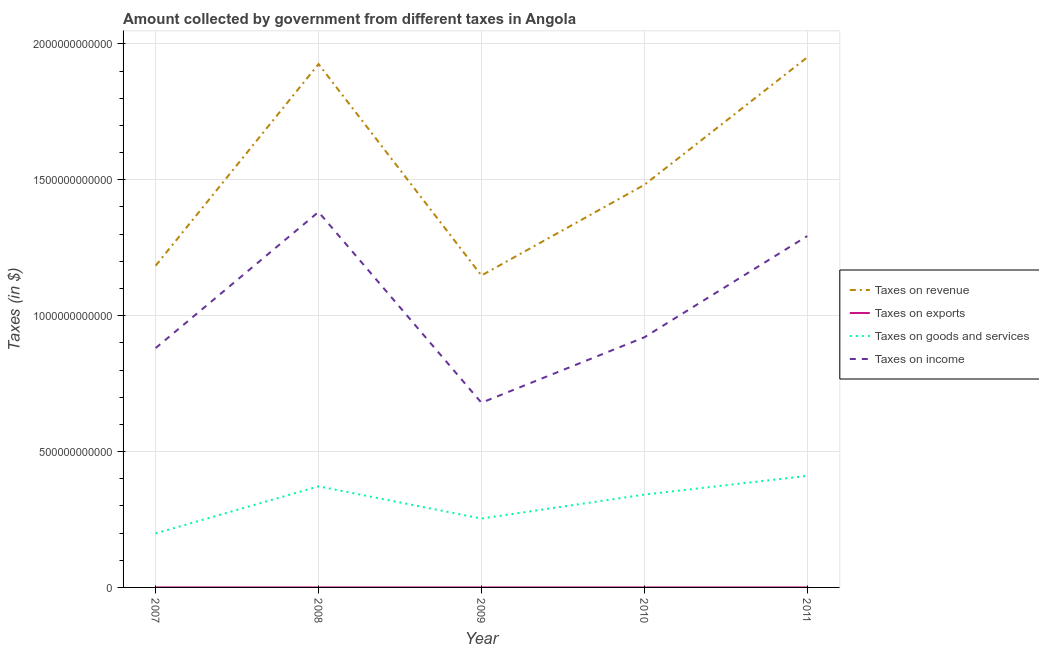How many different coloured lines are there?
Offer a very short reply. 4. Is the number of lines equal to the number of legend labels?
Provide a short and direct response. Yes. What is the amount collected as tax on income in 2010?
Provide a short and direct response. 9.20e+11. Across all years, what is the maximum amount collected as tax on goods?
Make the answer very short. 4.10e+11. Across all years, what is the minimum amount collected as tax on exports?
Ensure brevity in your answer.  7.26e+06. In which year was the amount collected as tax on goods minimum?
Offer a very short reply. 2007. What is the total amount collected as tax on goods in the graph?
Keep it short and to the point. 1.58e+12. What is the difference between the amount collected as tax on goods in 2007 and that in 2010?
Your answer should be very brief. -1.43e+11. What is the difference between the amount collected as tax on exports in 2011 and the amount collected as tax on income in 2010?
Give a very brief answer. -9.20e+11. What is the average amount collected as tax on income per year?
Provide a short and direct response. 1.03e+12. In the year 2010, what is the difference between the amount collected as tax on income and amount collected as tax on revenue?
Make the answer very short. -5.61e+11. What is the ratio of the amount collected as tax on income in 2007 to that in 2010?
Keep it short and to the point. 0.96. What is the difference between the highest and the second highest amount collected as tax on revenue?
Provide a short and direct response. 2.48e+1. What is the difference between the highest and the lowest amount collected as tax on revenue?
Give a very brief answer. 8.03e+11. Is the sum of the amount collected as tax on income in 2010 and 2011 greater than the maximum amount collected as tax on goods across all years?
Provide a short and direct response. Yes. Is it the case that in every year, the sum of the amount collected as tax on income and amount collected as tax on goods is greater than the sum of amount collected as tax on exports and amount collected as tax on revenue?
Provide a succinct answer. Yes. Is it the case that in every year, the sum of the amount collected as tax on revenue and amount collected as tax on exports is greater than the amount collected as tax on goods?
Give a very brief answer. Yes. Does the amount collected as tax on income monotonically increase over the years?
Keep it short and to the point. No. Is the amount collected as tax on goods strictly greater than the amount collected as tax on revenue over the years?
Ensure brevity in your answer.  No. Is the amount collected as tax on goods strictly less than the amount collected as tax on revenue over the years?
Make the answer very short. Yes. How many years are there in the graph?
Provide a succinct answer. 5. What is the difference between two consecutive major ticks on the Y-axis?
Keep it short and to the point. 5.00e+11. Does the graph contain grids?
Provide a short and direct response. Yes. How are the legend labels stacked?
Give a very brief answer. Vertical. What is the title of the graph?
Your response must be concise. Amount collected by government from different taxes in Angola. What is the label or title of the X-axis?
Provide a succinct answer. Year. What is the label or title of the Y-axis?
Offer a terse response. Taxes (in $). What is the Taxes (in $) in Taxes on revenue in 2007?
Offer a terse response. 1.18e+12. What is the Taxes (in $) of Taxes on exports in 2007?
Make the answer very short. 7.12e+07. What is the Taxes (in $) of Taxes on goods and services in 2007?
Offer a terse response. 1.99e+11. What is the Taxes (in $) in Taxes on income in 2007?
Your answer should be compact. 8.81e+11. What is the Taxes (in $) of Taxes on revenue in 2008?
Your answer should be very brief. 1.93e+12. What is the Taxes (in $) of Taxes on exports in 2008?
Give a very brief answer. 9.73e+06. What is the Taxes (in $) in Taxes on goods and services in 2008?
Offer a terse response. 3.72e+11. What is the Taxes (in $) in Taxes on income in 2008?
Make the answer very short. 1.38e+12. What is the Taxes (in $) of Taxes on revenue in 2009?
Make the answer very short. 1.15e+12. What is the Taxes (in $) of Taxes on exports in 2009?
Provide a short and direct response. 7.26e+06. What is the Taxes (in $) in Taxes on goods and services in 2009?
Your response must be concise. 2.53e+11. What is the Taxes (in $) of Taxes on income in 2009?
Provide a short and direct response. 6.80e+11. What is the Taxes (in $) in Taxes on revenue in 2010?
Provide a short and direct response. 1.48e+12. What is the Taxes (in $) in Taxes on exports in 2010?
Your answer should be very brief. 1.07e+07. What is the Taxes (in $) of Taxes on goods and services in 2010?
Your response must be concise. 3.42e+11. What is the Taxes (in $) in Taxes on income in 2010?
Your response must be concise. 9.20e+11. What is the Taxes (in $) of Taxes on revenue in 2011?
Your answer should be compact. 1.95e+12. What is the Taxes (in $) of Taxes on exports in 2011?
Provide a short and direct response. 1.11e+07. What is the Taxes (in $) in Taxes on goods and services in 2011?
Your answer should be compact. 4.10e+11. What is the Taxes (in $) of Taxes on income in 2011?
Offer a terse response. 1.29e+12. Across all years, what is the maximum Taxes (in $) of Taxes on revenue?
Keep it short and to the point. 1.95e+12. Across all years, what is the maximum Taxes (in $) in Taxes on exports?
Keep it short and to the point. 7.12e+07. Across all years, what is the maximum Taxes (in $) of Taxes on goods and services?
Your response must be concise. 4.10e+11. Across all years, what is the maximum Taxes (in $) in Taxes on income?
Ensure brevity in your answer.  1.38e+12. Across all years, what is the minimum Taxes (in $) of Taxes on revenue?
Keep it short and to the point. 1.15e+12. Across all years, what is the minimum Taxes (in $) of Taxes on exports?
Keep it short and to the point. 7.26e+06. Across all years, what is the minimum Taxes (in $) in Taxes on goods and services?
Your response must be concise. 1.99e+11. Across all years, what is the minimum Taxes (in $) of Taxes on income?
Offer a terse response. 6.80e+11. What is the total Taxes (in $) in Taxes on revenue in the graph?
Your answer should be compact. 7.69e+12. What is the total Taxes (in $) in Taxes on exports in the graph?
Make the answer very short. 1.10e+08. What is the total Taxes (in $) in Taxes on goods and services in the graph?
Offer a terse response. 1.58e+12. What is the total Taxes (in $) in Taxes on income in the graph?
Offer a very short reply. 5.16e+12. What is the difference between the Taxes (in $) in Taxes on revenue in 2007 and that in 2008?
Provide a succinct answer. -7.42e+11. What is the difference between the Taxes (in $) in Taxes on exports in 2007 and that in 2008?
Make the answer very short. 6.14e+07. What is the difference between the Taxes (in $) of Taxes on goods and services in 2007 and that in 2008?
Provide a short and direct response. -1.73e+11. What is the difference between the Taxes (in $) of Taxes on income in 2007 and that in 2008?
Keep it short and to the point. -5.01e+11. What is the difference between the Taxes (in $) of Taxes on revenue in 2007 and that in 2009?
Give a very brief answer. 3.61e+1. What is the difference between the Taxes (in $) in Taxes on exports in 2007 and that in 2009?
Give a very brief answer. 6.39e+07. What is the difference between the Taxes (in $) in Taxes on goods and services in 2007 and that in 2009?
Ensure brevity in your answer.  -5.47e+1. What is the difference between the Taxes (in $) of Taxes on income in 2007 and that in 2009?
Your response must be concise. 2.01e+11. What is the difference between the Taxes (in $) in Taxes on revenue in 2007 and that in 2010?
Provide a succinct answer. -2.97e+11. What is the difference between the Taxes (in $) in Taxes on exports in 2007 and that in 2010?
Offer a terse response. 6.04e+07. What is the difference between the Taxes (in $) of Taxes on goods and services in 2007 and that in 2010?
Your answer should be compact. -1.43e+11. What is the difference between the Taxes (in $) in Taxes on income in 2007 and that in 2010?
Make the answer very short. -3.97e+1. What is the difference between the Taxes (in $) in Taxes on revenue in 2007 and that in 2011?
Provide a short and direct response. -7.67e+11. What is the difference between the Taxes (in $) in Taxes on exports in 2007 and that in 2011?
Keep it short and to the point. 6.00e+07. What is the difference between the Taxes (in $) of Taxes on goods and services in 2007 and that in 2011?
Give a very brief answer. -2.12e+11. What is the difference between the Taxes (in $) in Taxes on income in 2007 and that in 2011?
Provide a short and direct response. -4.12e+11. What is the difference between the Taxes (in $) of Taxes on revenue in 2008 and that in 2009?
Provide a short and direct response. 7.78e+11. What is the difference between the Taxes (in $) in Taxes on exports in 2008 and that in 2009?
Keep it short and to the point. 2.47e+06. What is the difference between the Taxes (in $) in Taxes on goods and services in 2008 and that in 2009?
Your answer should be compact. 1.18e+11. What is the difference between the Taxes (in $) in Taxes on income in 2008 and that in 2009?
Offer a terse response. 7.02e+11. What is the difference between the Taxes (in $) in Taxes on revenue in 2008 and that in 2010?
Provide a succinct answer. 4.44e+11. What is the difference between the Taxes (in $) of Taxes on exports in 2008 and that in 2010?
Keep it short and to the point. -9.83e+05. What is the difference between the Taxes (in $) of Taxes on goods and services in 2008 and that in 2010?
Offer a terse response. 3.04e+1. What is the difference between the Taxes (in $) in Taxes on income in 2008 and that in 2010?
Provide a short and direct response. 4.61e+11. What is the difference between the Taxes (in $) of Taxes on revenue in 2008 and that in 2011?
Make the answer very short. -2.48e+1. What is the difference between the Taxes (in $) in Taxes on exports in 2008 and that in 2011?
Make the answer very short. -1.39e+06. What is the difference between the Taxes (in $) in Taxes on goods and services in 2008 and that in 2011?
Provide a succinct answer. -3.86e+1. What is the difference between the Taxes (in $) in Taxes on income in 2008 and that in 2011?
Give a very brief answer. 8.87e+1. What is the difference between the Taxes (in $) of Taxes on revenue in 2009 and that in 2010?
Keep it short and to the point. -3.34e+11. What is the difference between the Taxes (in $) in Taxes on exports in 2009 and that in 2010?
Your response must be concise. -3.46e+06. What is the difference between the Taxes (in $) in Taxes on goods and services in 2009 and that in 2010?
Your answer should be compact. -8.80e+1. What is the difference between the Taxes (in $) in Taxes on income in 2009 and that in 2010?
Make the answer very short. -2.41e+11. What is the difference between the Taxes (in $) in Taxes on revenue in 2009 and that in 2011?
Offer a terse response. -8.03e+11. What is the difference between the Taxes (in $) in Taxes on exports in 2009 and that in 2011?
Your answer should be compact. -3.86e+06. What is the difference between the Taxes (in $) in Taxes on goods and services in 2009 and that in 2011?
Provide a short and direct response. -1.57e+11. What is the difference between the Taxes (in $) of Taxes on income in 2009 and that in 2011?
Offer a very short reply. -6.13e+11. What is the difference between the Taxes (in $) in Taxes on revenue in 2010 and that in 2011?
Provide a succinct answer. -4.69e+11. What is the difference between the Taxes (in $) in Taxes on exports in 2010 and that in 2011?
Provide a succinct answer. -4.03e+05. What is the difference between the Taxes (in $) in Taxes on goods and services in 2010 and that in 2011?
Ensure brevity in your answer.  -6.89e+1. What is the difference between the Taxes (in $) of Taxes on income in 2010 and that in 2011?
Provide a succinct answer. -3.73e+11. What is the difference between the Taxes (in $) of Taxes on revenue in 2007 and the Taxes (in $) of Taxes on exports in 2008?
Provide a succinct answer. 1.18e+12. What is the difference between the Taxes (in $) in Taxes on revenue in 2007 and the Taxes (in $) in Taxes on goods and services in 2008?
Keep it short and to the point. 8.12e+11. What is the difference between the Taxes (in $) in Taxes on revenue in 2007 and the Taxes (in $) in Taxes on income in 2008?
Your answer should be very brief. -1.98e+11. What is the difference between the Taxes (in $) in Taxes on exports in 2007 and the Taxes (in $) in Taxes on goods and services in 2008?
Offer a very short reply. -3.72e+11. What is the difference between the Taxes (in $) in Taxes on exports in 2007 and the Taxes (in $) in Taxes on income in 2008?
Provide a succinct answer. -1.38e+12. What is the difference between the Taxes (in $) in Taxes on goods and services in 2007 and the Taxes (in $) in Taxes on income in 2008?
Make the answer very short. -1.18e+12. What is the difference between the Taxes (in $) in Taxes on revenue in 2007 and the Taxes (in $) in Taxes on exports in 2009?
Give a very brief answer. 1.18e+12. What is the difference between the Taxes (in $) in Taxes on revenue in 2007 and the Taxes (in $) in Taxes on goods and services in 2009?
Offer a terse response. 9.30e+11. What is the difference between the Taxes (in $) in Taxes on revenue in 2007 and the Taxes (in $) in Taxes on income in 2009?
Your answer should be compact. 5.04e+11. What is the difference between the Taxes (in $) in Taxes on exports in 2007 and the Taxes (in $) in Taxes on goods and services in 2009?
Your answer should be compact. -2.53e+11. What is the difference between the Taxes (in $) of Taxes on exports in 2007 and the Taxes (in $) of Taxes on income in 2009?
Make the answer very short. -6.80e+11. What is the difference between the Taxes (in $) in Taxes on goods and services in 2007 and the Taxes (in $) in Taxes on income in 2009?
Offer a very short reply. -4.81e+11. What is the difference between the Taxes (in $) of Taxes on revenue in 2007 and the Taxes (in $) of Taxes on exports in 2010?
Ensure brevity in your answer.  1.18e+12. What is the difference between the Taxes (in $) of Taxes on revenue in 2007 and the Taxes (in $) of Taxes on goods and services in 2010?
Provide a succinct answer. 8.42e+11. What is the difference between the Taxes (in $) in Taxes on revenue in 2007 and the Taxes (in $) in Taxes on income in 2010?
Your response must be concise. 2.64e+11. What is the difference between the Taxes (in $) of Taxes on exports in 2007 and the Taxes (in $) of Taxes on goods and services in 2010?
Offer a terse response. -3.41e+11. What is the difference between the Taxes (in $) in Taxes on exports in 2007 and the Taxes (in $) in Taxes on income in 2010?
Provide a succinct answer. -9.20e+11. What is the difference between the Taxes (in $) in Taxes on goods and services in 2007 and the Taxes (in $) in Taxes on income in 2010?
Provide a succinct answer. -7.22e+11. What is the difference between the Taxes (in $) of Taxes on revenue in 2007 and the Taxes (in $) of Taxes on exports in 2011?
Your answer should be very brief. 1.18e+12. What is the difference between the Taxes (in $) of Taxes on revenue in 2007 and the Taxes (in $) of Taxes on goods and services in 2011?
Make the answer very short. 7.73e+11. What is the difference between the Taxes (in $) of Taxes on revenue in 2007 and the Taxes (in $) of Taxes on income in 2011?
Your answer should be very brief. -1.09e+11. What is the difference between the Taxes (in $) in Taxes on exports in 2007 and the Taxes (in $) in Taxes on goods and services in 2011?
Keep it short and to the point. -4.10e+11. What is the difference between the Taxes (in $) in Taxes on exports in 2007 and the Taxes (in $) in Taxes on income in 2011?
Your answer should be very brief. -1.29e+12. What is the difference between the Taxes (in $) in Taxes on goods and services in 2007 and the Taxes (in $) in Taxes on income in 2011?
Offer a very short reply. -1.09e+12. What is the difference between the Taxes (in $) in Taxes on revenue in 2008 and the Taxes (in $) in Taxes on exports in 2009?
Your response must be concise. 1.93e+12. What is the difference between the Taxes (in $) in Taxes on revenue in 2008 and the Taxes (in $) in Taxes on goods and services in 2009?
Offer a terse response. 1.67e+12. What is the difference between the Taxes (in $) of Taxes on revenue in 2008 and the Taxes (in $) of Taxes on income in 2009?
Ensure brevity in your answer.  1.25e+12. What is the difference between the Taxes (in $) of Taxes on exports in 2008 and the Taxes (in $) of Taxes on goods and services in 2009?
Offer a very short reply. -2.53e+11. What is the difference between the Taxes (in $) in Taxes on exports in 2008 and the Taxes (in $) in Taxes on income in 2009?
Provide a succinct answer. -6.80e+11. What is the difference between the Taxes (in $) of Taxes on goods and services in 2008 and the Taxes (in $) of Taxes on income in 2009?
Your response must be concise. -3.08e+11. What is the difference between the Taxes (in $) in Taxes on revenue in 2008 and the Taxes (in $) in Taxes on exports in 2010?
Offer a very short reply. 1.93e+12. What is the difference between the Taxes (in $) of Taxes on revenue in 2008 and the Taxes (in $) of Taxes on goods and services in 2010?
Give a very brief answer. 1.58e+12. What is the difference between the Taxes (in $) of Taxes on revenue in 2008 and the Taxes (in $) of Taxes on income in 2010?
Offer a terse response. 1.01e+12. What is the difference between the Taxes (in $) in Taxes on exports in 2008 and the Taxes (in $) in Taxes on goods and services in 2010?
Your answer should be very brief. -3.42e+11. What is the difference between the Taxes (in $) of Taxes on exports in 2008 and the Taxes (in $) of Taxes on income in 2010?
Your answer should be very brief. -9.20e+11. What is the difference between the Taxes (in $) in Taxes on goods and services in 2008 and the Taxes (in $) in Taxes on income in 2010?
Your answer should be very brief. -5.48e+11. What is the difference between the Taxes (in $) of Taxes on revenue in 2008 and the Taxes (in $) of Taxes on exports in 2011?
Provide a succinct answer. 1.93e+12. What is the difference between the Taxes (in $) of Taxes on revenue in 2008 and the Taxes (in $) of Taxes on goods and services in 2011?
Your response must be concise. 1.52e+12. What is the difference between the Taxes (in $) in Taxes on revenue in 2008 and the Taxes (in $) in Taxes on income in 2011?
Offer a terse response. 6.33e+11. What is the difference between the Taxes (in $) in Taxes on exports in 2008 and the Taxes (in $) in Taxes on goods and services in 2011?
Your answer should be very brief. -4.10e+11. What is the difference between the Taxes (in $) of Taxes on exports in 2008 and the Taxes (in $) of Taxes on income in 2011?
Ensure brevity in your answer.  -1.29e+12. What is the difference between the Taxes (in $) of Taxes on goods and services in 2008 and the Taxes (in $) of Taxes on income in 2011?
Offer a terse response. -9.21e+11. What is the difference between the Taxes (in $) of Taxes on revenue in 2009 and the Taxes (in $) of Taxes on exports in 2010?
Your answer should be compact. 1.15e+12. What is the difference between the Taxes (in $) in Taxes on revenue in 2009 and the Taxes (in $) in Taxes on goods and services in 2010?
Your response must be concise. 8.06e+11. What is the difference between the Taxes (in $) in Taxes on revenue in 2009 and the Taxes (in $) in Taxes on income in 2010?
Provide a succinct answer. 2.27e+11. What is the difference between the Taxes (in $) of Taxes on exports in 2009 and the Taxes (in $) of Taxes on goods and services in 2010?
Your answer should be compact. -3.42e+11. What is the difference between the Taxes (in $) in Taxes on exports in 2009 and the Taxes (in $) in Taxes on income in 2010?
Keep it short and to the point. -9.20e+11. What is the difference between the Taxes (in $) of Taxes on goods and services in 2009 and the Taxes (in $) of Taxes on income in 2010?
Your response must be concise. -6.67e+11. What is the difference between the Taxes (in $) of Taxes on revenue in 2009 and the Taxes (in $) of Taxes on exports in 2011?
Give a very brief answer. 1.15e+12. What is the difference between the Taxes (in $) in Taxes on revenue in 2009 and the Taxes (in $) in Taxes on goods and services in 2011?
Offer a very short reply. 7.37e+11. What is the difference between the Taxes (in $) in Taxes on revenue in 2009 and the Taxes (in $) in Taxes on income in 2011?
Provide a short and direct response. -1.45e+11. What is the difference between the Taxes (in $) of Taxes on exports in 2009 and the Taxes (in $) of Taxes on goods and services in 2011?
Offer a very short reply. -4.10e+11. What is the difference between the Taxes (in $) in Taxes on exports in 2009 and the Taxes (in $) in Taxes on income in 2011?
Give a very brief answer. -1.29e+12. What is the difference between the Taxes (in $) of Taxes on goods and services in 2009 and the Taxes (in $) of Taxes on income in 2011?
Ensure brevity in your answer.  -1.04e+12. What is the difference between the Taxes (in $) in Taxes on revenue in 2010 and the Taxes (in $) in Taxes on exports in 2011?
Ensure brevity in your answer.  1.48e+12. What is the difference between the Taxes (in $) in Taxes on revenue in 2010 and the Taxes (in $) in Taxes on goods and services in 2011?
Offer a very short reply. 1.07e+12. What is the difference between the Taxes (in $) of Taxes on revenue in 2010 and the Taxes (in $) of Taxes on income in 2011?
Ensure brevity in your answer.  1.88e+11. What is the difference between the Taxes (in $) in Taxes on exports in 2010 and the Taxes (in $) in Taxes on goods and services in 2011?
Your answer should be compact. -4.10e+11. What is the difference between the Taxes (in $) in Taxes on exports in 2010 and the Taxes (in $) in Taxes on income in 2011?
Keep it short and to the point. -1.29e+12. What is the difference between the Taxes (in $) in Taxes on goods and services in 2010 and the Taxes (in $) in Taxes on income in 2011?
Your answer should be compact. -9.51e+11. What is the average Taxes (in $) in Taxes on revenue per year?
Ensure brevity in your answer.  1.54e+12. What is the average Taxes (in $) in Taxes on exports per year?
Make the answer very short. 2.20e+07. What is the average Taxes (in $) of Taxes on goods and services per year?
Ensure brevity in your answer.  3.15e+11. What is the average Taxes (in $) in Taxes on income per year?
Give a very brief answer. 1.03e+12. In the year 2007, what is the difference between the Taxes (in $) of Taxes on revenue and Taxes (in $) of Taxes on exports?
Your answer should be very brief. 1.18e+12. In the year 2007, what is the difference between the Taxes (in $) in Taxes on revenue and Taxes (in $) in Taxes on goods and services?
Make the answer very short. 9.85e+11. In the year 2007, what is the difference between the Taxes (in $) of Taxes on revenue and Taxes (in $) of Taxes on income?
Provide a short and direct response. 3.03e+11. In the year 2007, what is the difference between the Taxes (in $) in Taxes on exports and Taxes (in $) in Taxes on goods and services?
Your answer should be very brief. -1.99e+11. In the year 2007, what is the difference between the Taxes (in $) in Taxes on exports and Taxes (in $) in Taxes on income?
Your answer should be compact. -8.81e+11. In the year 2007, what is the difference between the Taxes (in $) in Taxes on goods and services and Taxes (in $) in Taxes on income?
Ensure brevity in your answer.  -6.82e+11. In the year 2008, what is the difference between the Taxes (in $) of Taxes on revenue and Taxes (in $) of Taxes on exports?
Your response must be concise. 1.93e+12. In the year 2008, what is the difference between the Taxes (in $) in Taxes on revenue and Taxes (in $) in Taxes on goods and services?
Your response must be concise. 1.55e+12. In the year 2008, what is the difference between the Taxes (in $) in Taxes on revenue and Taxes (in $) in Taxes on income?
Provide a succinct answer. 5.44e+11. In the year 2008, what is the difference between the Taxes (in $) of Taxes on exports and Taxes (in $) of Taxes on goods and services?
Ensure brevity in your answer.  -3.72e+11. In the year 2008, what is the difference between the Taxes (in $) of Taxes on exports and Taxes (in $) of Taxes on income?
Offer a very short reply. -1.38e+12. In the year 2008, what is the difference between the Taxes (in $) of Taxes on goods and services and Taxes (in $) of Taxes on income?
Provide a short and direct response. -1.01e+12. In the year 2009, what is the difference between the Taxes (in $) of Taxes on revenue and Taxes (in $) of Taxes on exports?
Give a very brief answer. 1.15e+12. In the year 2009, what is the difference between the Taxes (in $) of Taxes on revenue and Taxes (in $) of Taxes on goods and services?
Offer a very short reply. 8.94e+11. In the year 2009, what is the difference between the Taxes (in $) in Taxes on revenue and Taxes (in $) in Taxes on income?
Your response must be concise. 4.68e+11. In the year 2009, what is the difference between the Taxes (in $) of Taxes on exports and Taxes (in $) of Taxes on goods and services?
Your answer should be compact. -2.53e+11. In the year 2009, what is the difference between the Taxes (in $) in Taxes on exports and Taxes (in $) in Taxes on income?
Offer a very short reply. -6.80e+11. In the year 2009, what is the difference between the Taxes (in $) of Taxes on goods and services and Taxes (in $) of Taxes on income?
Offer a very short reply. -4.26e+11. In the year 2010, what is the difference between the Taxes (in $) of Taxes on revenue and Taxes (in $) of Taxes on exports?
Your answer should be compact. 1.48e+12. In the year 2010, what is the difference between the Taxes (in $) of Taxes on revenue and Taxes (in $) of Taxes on goods and services?
Keep it short and to the point. 1.14e+12. In the year 2010, what is the difference between the Taxes (in $) of Taxes on revenue and Taxes (in $) of Taxes on income?
Your response must be concise. 5.61e+11. In the year 2010, what is the difference between the Taxes (in $) of Taxes on exports and Taxes (in $) of Taxes on goods and services?
Make the answer very short. -3.42e+11. In the year 2010, what is the difference between the Taxes (in $) in Taxes on exports and Taxes (in $) in Taxes on income?
Keep it short and to the point. -9.20e+11. In the year 2010, what is the difference between the Taxes (in $) of Taxes on goods and services and Taxes (in $) of Taxes on income?
Offer a terse response. -5.79e+11. In the year 2011, what is the difference between the Taxes (in $) in Taxes on revenue and Taxes (in $) in Taxes on exports?
Provide a succinct answer. 1.95e+12. In the year 2011, what is the difference between the Taxes (in $) of Taxes on revenue and Taxes (in $) of Taxes on goods and services?
Keep it short and to the point. 1.54e+12. In the year 2011, what is the difference between the Taxes (in $) in Taxes on revenue and Taxes (in $) in Taxes on income?
Offer a terse response. 6.58e+11. In the year 2011, what is the difference between the Taxes (in $) of Taxes on exports and Taxes (in $) of Taxes on goods and services?
Ensure brevity in your answer.  -4.10e+11. In the year 2011, what is the difference between the Taxes (in $) of Taxes on exports and Taxes (in $) of Taxes on income?
Make the answer very short. -1.29e+12. In the year 2011, what is the difference between the Taxes (in $) of Taxes on goods and services and Taxes (in $) of Taxes on income?
Give a very brief answer. -8.82e+11. What is the ratio of the Taxes (in $) of Taxes on revenue in 2007 to that in 2008?
Your response must be concise. 0.61. What is the ratio of the Taxes (in $) of Taxes on exports in 2007 to that in 2008?
Provide a short and direct response. 7.31. What is the ratio of the Taxes (in $) of Taxes on goods and services in 2007 to that in 2008?
Provide a short and direct response. 0.53. What is the ratio of the Taxes (in $) in Taxes on income in 2007 to that in 2008?
Provide a succinct answer. 0.64. What is the ratio of the Taxes (in $) of Taxes on revenue in 2007 to that in 2009?
Make the answer very short. 1.03. What is the ratio of the Taxes (in $) of Taxes on exports in 2007 to that in 2009?
Keep it short and to the point. 9.8. What is the ratio of the Taxes (in $) of Taxes on goods and services in 2007 to that in 2009?
Provide a short and direct response. 0.78. What is the ratio of the Taxes (in $) of Taxes on income in 2007 to that in 2009?
Your answer should be compact. 1.3. What is the ratio of the Taxes (in $) in Taxes on revenue in 2007 to that in 2010?
Make the answer very short. 0.8. What is the ratio of the Taxes (in $) of Taxes on exports in 2007 to that in 2010?
Ensure brevity in your answer.  6.64. What is the ratio of the Taxes (in $) in Taxes on goods and services in 2007 to that in 2010?
Your answer should be compact. 0.58. What is the ratio of the Taxes (in $) of Taxes on income in 2007 to that in 2010?
Your answer should be compact. 0.96. What is the ratio of the Taxes (in $) in Taxes on revenue in 2007 to that in 2011?
Provide a short and direct response. 0.61. What is the ratio of the Taxes (in $) in Taxes on exports in 2007 to that in 2011?
Provide a short and direct response. 6.4. What is the ratio of the Taxes (in $) of Taxes on goods and services in 2007 to that in 2011?
Offer a very short reply. 0.48. What is the ratio of the Taxes (in $) of Taxes on income in 2007 to that in 2011?
Ensure brevity in your answer.  0.68. What is the ratio of the Taxes (in $) in Taxes on revenue in 2008 to that in 2009?
Offer a terse response. 1.68. What is the ratio of the Taxes (in $) of Taxes on exports in 2008 to that in 2009?
Your response must be concise. 1.34. What is the ratio of the Taxes (in $) in Taxes on goods and services in 2008 to that in 2009?
Offer a terse response. 1.47. What is the ratio of the Taxes (in $) of Taxes on income in 2008 to that in 2009?
Provide a succinct answer. 2.03. What is the ratio of the Taxes (in $) of Taxes on exports in 2008 to that in 2010?
Your response must be concise. 0.91. What is the ratio of the Taxes (in $) of Taxes on goods and services in 2008 to that in 2010?
Offer a terse response. 1.09. What is the ratio of the Taxes (in $) of Taxes on income in 2008 to that in 2010?
Your answer should be very brief. 1.5. What is the ratio of the Taxes (in $) of Taxes on revenue in 2008 to that in 2011?
Offer a very short reply. 0.99. What is the ratio of the Taxes (in $) in Taxes on exports in 2008 to that in 2011?
Provide a succinct answer. 0.88. What is the ratio of the Taxes (in $) of Taxes on goods and services in 2008 to that in 2011?
Your response must be concise. 0.91. What is the ratio of the Taxes (in $) of Taxes on income in 2008 to that in 2011?
Provide a succinct answer. 1.07. What is the ratio of the Taxes (in $) in Taxes on revenue in 2009 to that in 2010?
Make the answer very short. 0.77. What is the ratio of the Taxes (in $) in Taxes on exports in 2009 to that in 2010?
Provide a short and direct response. 0.68. What is the ratio of the Taxes (in $) in Taxes on goods and services in 2009 to that in 2010?
Make the answer very short. 0.74. What is the ratio of the Taxes (in $) in Taxes on income in 2009 to that in 2010?
Provide a short and direct response. 0.74. What is the ratio of the Taxes (in $) in Taxes on revenue in 2009 to that in 2011?
Your response must be concise. 0.59. What is the ratio of the Taxes (in $) in Taxes on exports in 2009 to that in 2011?
Make the answer very short. 0.65. What is the ratio of the Taxes (in $) in Taxes on goods and services in 2009 to that in 2011?
Keep it short and to the point. 0.62. What is the ratio of the Taxes (in $) of Taxes on income in 2009 to that in 2011?
Offer a terse response. 0.53. What is the ratio of the Taxes (in $) of Taxes on revenue in 2010 to that in 2011?
Offer a terse response. 0.76. What is the ratio of the Taxes (in $) of Taxes on exports in 2010 to that in 2011?
Provide a succinct answer. 0.96. What is the ratio of the Taxes (in $) of Taxes on goods and services in 2010 to that in 2011?
Your answer should be compact. 0.83. What is the ratio of the Taxes (in $) of Taxes on income in 2010 to that in 2011?
Offer a terse response. 0.71. What is the difference between the highest and the second highest Taxes (in $) in Taxes on revenue?
Keep it short and to the point. 2.48e+1. What is the difference between the highest and the second highest Taxes (in $) of Taxes on exports?
Provide a succinct answer. 6.00e+07. What is the difference between the highest and the second highest Taxes (in $) of Taxes on goods and services?
Your response must be concise. 3.86e+1. What is the difference between the highest and the second highest Taxes (in $) in Taxes on income?
Ensure brevity in your answer.  8.87e+1. What is the difference between the highest and the lowest Taxes (in $) in Taxes on revenue?
Provide a short and direct response. 8.03e+11. What is the difference between the highest and the lowest Taxes (in $) in Taxes on exports?
Keep it short and to the point. 6.39e+07. What is the difference between the highest and the lowest Taxes (in $) of Taxes on goods and services?
Your response must be concise. 2.12e+11. What is the difference between the highest and the lowest Taxes (in $) of Taxes on income?
Keep it short and to the point. 7.02e+11. 